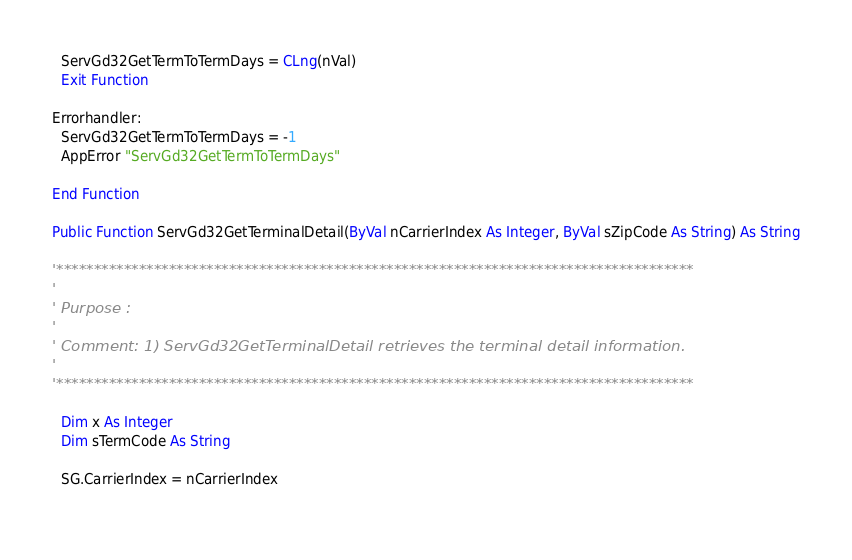<code> <loc_0><loc_0><loc_500><loc_500><_VisualBasic_>  ServGd32GetTermToTermDays = CLng(nVal)
  Exit Function

Errorhandler:
  ServGd32GetTermToTermDays = -1
  AppError "ServGd32GetTermToTermDays"
  
End Function

Public Function ServGd32GetTerminalDetail(ByVal nCarrierIndex As Integer, ByVal sZipCode As String) As String

'*************************************************************************************
'
' Purpose :
'
' Comment: 1) ServGd32GetTerminalDetail retrieves the terminal detail information.
'
'*************************************************************************************

  Dim x As Integer
  Dim sTermCode As String
  
  SG.CarrierIndex = nCarrierIndex
    </code> 